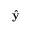<formula> <loc_0><loc_0><loc_500><loc_500>\hat { y }</formula> 